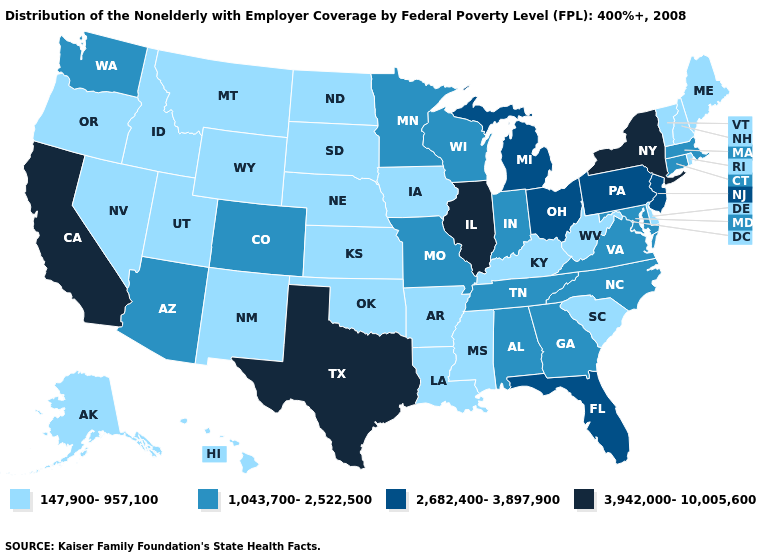Name the states that have a value in the range 3,942,000-10,005,600?
Write a very short answer. California, Illinois, New York, Texas. Among the states that border Missouri , which have the lowest value?
Short answer required. Arkansas, Iowa, Kansas, Kentucky, Nebraska, Oklahoma. Does Idaho have the highest value in the West?
Concise answer only. No. Among the states that border Louisiana , does Texas have the highest value?
Short answer required. Yes. Which states have the lowest value in the USA?
Answer briefly. Alaska, Arkansas, Delaware, Hawaii, Idaho, Iowa, Kansas, Kentucky, Louisiana, Maine, Mississippi, Montana, Nebraska, Nevada, New Hampshire, New Mexico, North Dakota, Oklahoma, Oregon, Rhode Island, South Carolina, South Dakota, Utah, Vermont, West Virginia, Wyoming. What is the lowest value in states that border Alabama?
Keep it brief. 147,900-957,100. Among the states that border Colorado , does Kansas have the highest value?
Give a very brief answer. No. Among the states that border Missouri , does Iowa have the lowest value?
Be succinct. Yes. Which states have the lowest value in the MidWest?
Keep it brief. Iowa, Kansas, Nebraska, North Dakota, South Dakota. Name the states that have a value in the range 147,900-957,100?
Quick response, please. Alaska, Arkansas, Delaware, Hawaii, Idaho, Iowa, Kansas, Kentucky, Louisiana, Maine, Mississippi, Montana, Nebraska, Nevada, New Hampshire, New Mexico, North Dakota, Oklahoma, Oregon, Rhode Island, South Carolina, South Dakota, Utah, Vermont, West Virginia, Wyoming. What is the value of Louisiana?
Give a very brief answer. 147,900-957,100. Among the states that border Kansas , which have the lowest value?
Be succinct. Nebraska, Oklahoma. What is the value of Wyoming?
Keep it brief. 147,900-957,100. Does Arkansas have the same value as New Hampshire?
Write a very short answer. Yes. Name the states that have a value in the range 147,900-957,100?
Give a very brief answer. Alaska, Arkansas, Delaware, Hawaii, Idaho, Iowa, Kansas, Kentucky, Louisiana, Maine, Mississippi, Montana, Nebraska, Nevada, New Hampshire, New Mexico, North Dakota, Oklahoma, Oregon, Rhode Island, South Carolina, South Dakota, Utah, Vermont, West Virginia, Wyoming. 